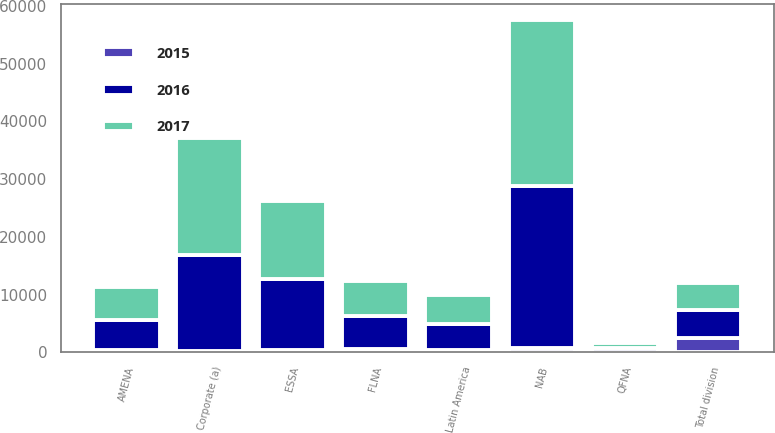Convert chart. <chart><loc_0><loc_0><loc_500><loc_500><stacked_bar_chart><ecel><fcel>FLNA<fcel>QFNA<fcel>NAB<fcel>Latin America<fcel>ESSA<fcel>AMENA<fcel>Total division<fcel>Corporate (a)<nl><fcel>2017<fcel>5979<fcel>804<fcel>28592<fcel>4976<fcel>13556<fcel>5668<fcel>4772<fcel>20229<nl><fcel>2016<fcel>5731<fcel>811<fcel>28172<fcel>4568<fcel>12302<fcel>5261<fcel>4772<fcel>16645<nl><fcel>2015<fcel>608<fcel>40<fcel>695<fcel>368<fcel>404<fcel>441<fcel>2556<fcel>202<nl></chart> 